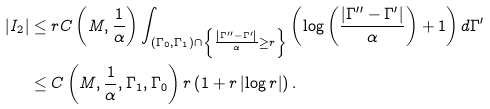Convert formula to latex. <formula><loc_0><loc_0><loc_500><loc_500>\left | I _ { 2 } \right | & \leq r C \left ( M , \frac { 1 } { \alpha } \right ) \int _ { \left ( \Gamma _ { 0 } , \Gamma _ { 1 } \right ) \cap \left \{ \frac { \left | \Gamma ^ { \prime \prime } - \Gamma ^ { \prime } \right | } { \alpha } \geq r \right \} } \left ( \log \left ( \frac { \left | \Gamma ^ { \prime \prime } - \Gamma ^ { \prime } \right | } { \alpha } \right ) + 1 \right ) d \Gamma ^ { \prime } \\ & \leq C \left ( M , \frac { 1 } { \alpha } , \Gamma _ { 1 } , \Gamma _ { 0 } \right ) r \left ( 1 + r \left | \log r \right | \right ) .</formula> 